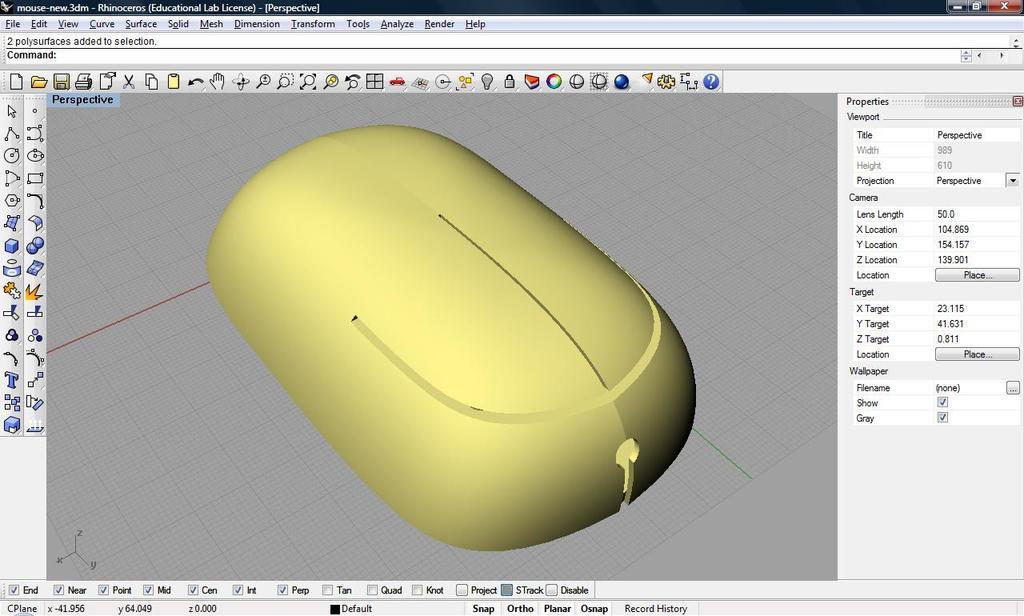Can you describe this image briefly? In this picture there is a screenshot of painting page. In the center we can see yellow color mouse drawing. Here we can see a icon bar. 